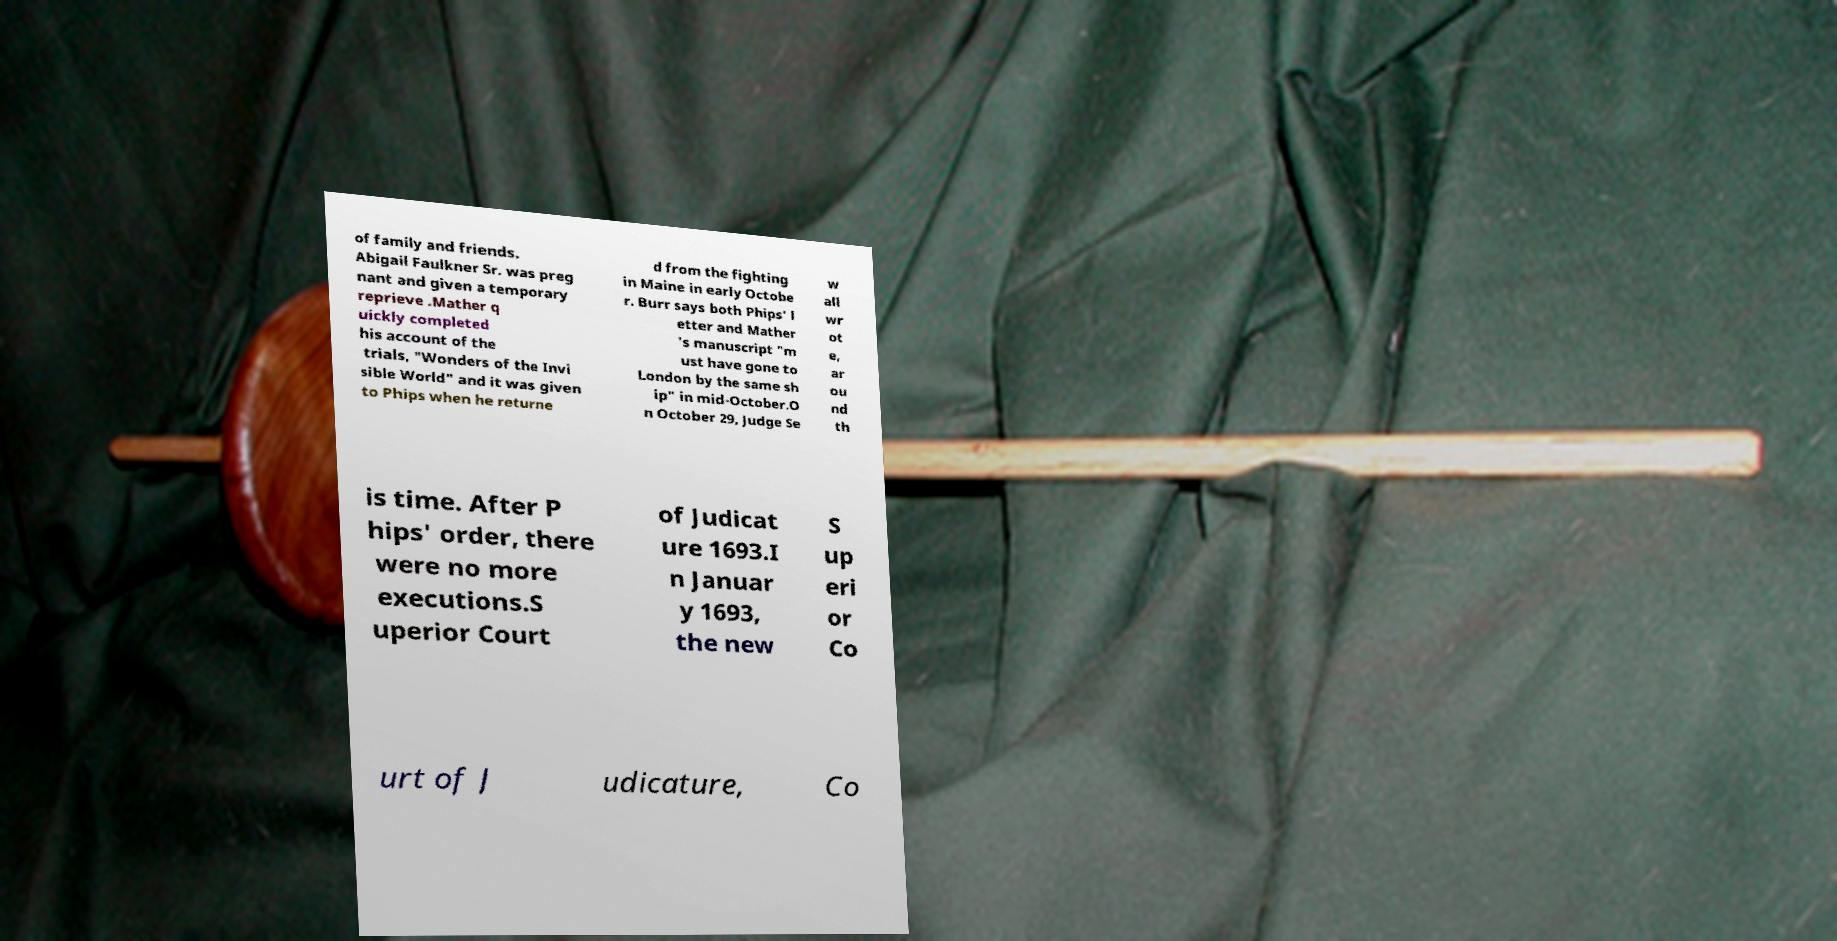Could you extract and type out the text from this image? of family and friends. Abigail Faulkner Sr. was preg nant and given a temporary reprieve .Mather q uickly completed his account of the trials, "Wonders of the Invi sible World" and it was given to Phips when he returne d from the fighting in Maine in early Octobe r. Burr says both Phips' l etter and Mather 's manuscript "m ust have gone to London by the same sh ip" in mid-October.O n October 29, Judge Se w all wr ot e, ar ou nd th is time. After P hips' order, there were no more executions.S uperior Court of Judicat ure 1693.I n Januar y 1693, the new S up eri or Co urt of J udicature, Co 